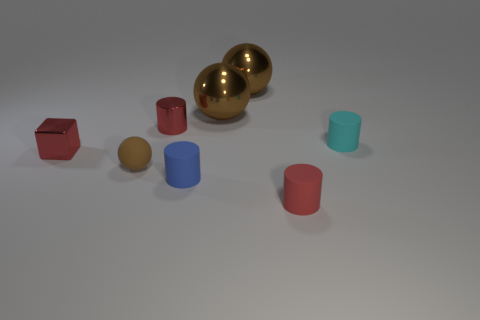How many brown balls must be subtracted to get 1 brown balls? 2 Subtract all small balls. How many balls are left? 2 Subtract 2 cylinders. How many cylinders are left? 2 Add 1 tiny blue spheres. How many objects exist? 9 Subtract all green cylinders. Subtract all yellow spheres. How many cylinders are left? 4 Subtract all cubes. How many objects are left? 7 Subtract all small brown spheres. Subtract all small metallic blocks. How many objects are left? 6 Add 2 blue cylinders. How many blue cylinders are left? 3 Add 6 tiny rubber blocks. How many tiny rubber blocks exist? 6 Subtract 0 cyan balls. How many objects are left? 8 